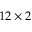<formula> <loc_0><loc_0><loc_500><loc_500>1 2 \times 2</formula> 